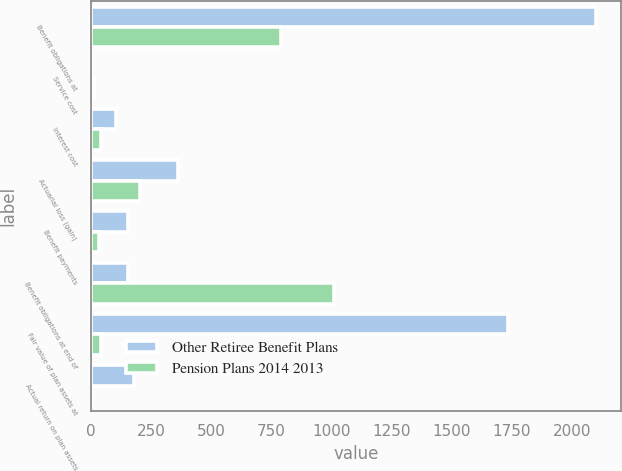<chart> <loc_0><loc_0><loc_500><loc_500><stacked_bar_chart><ecel><fcel>Benefit obligations at<fcel>Service cost<fcel>Interest cost<fcel>Actuarial loss (gain)<fcel>Benefit payments<fcel>Benefit obligations at end of<fcel>Fair value of plan assets at<fcel>Actual return on plan assets<nl><fcel>Other Retiree Benefit Plans<fcel>2102<fcel>1<fcel>102<fcel>362<fcel>154<fcel>154<fcel>1736<fcel>178<nl><fcel>Pension Plans 2014 2013<fcel>792<fcel>10<fcel>42<fcel>203<fcel>33<fcel>1011<fcel>41<fcel>4<nl></chart> 